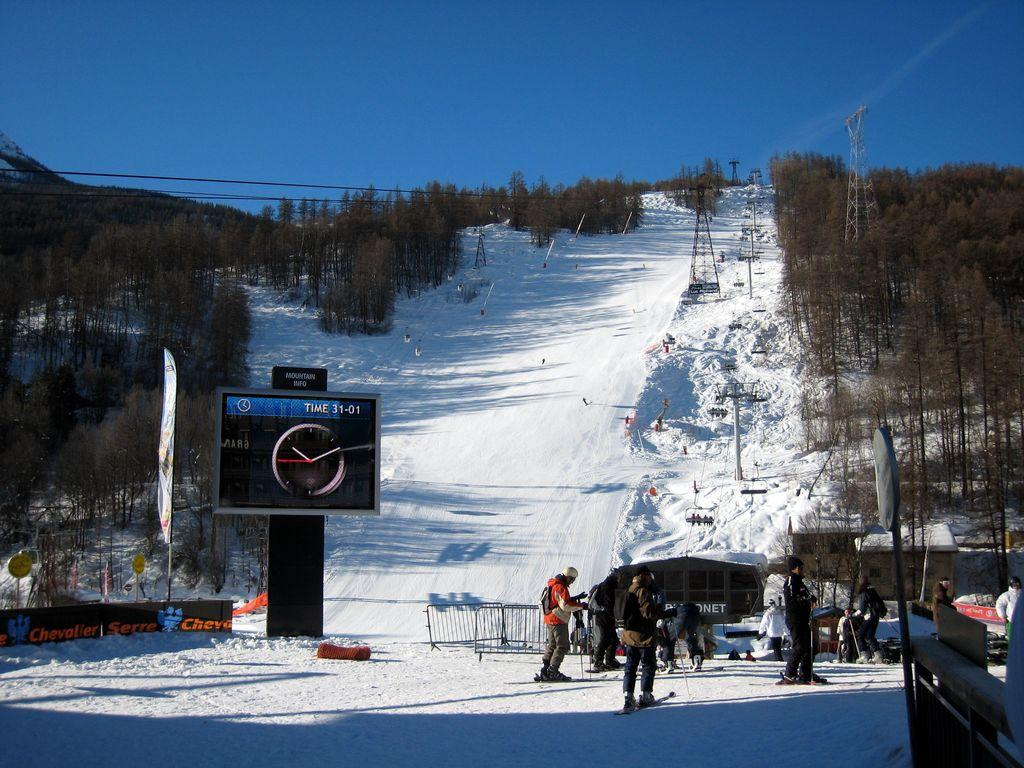What type of surface is depicted in the image? There is a piste in the image. What can be seen on the sides of the piste? The piste has trees and poles on its sides. What other objects or structures are present in the image? There are posters, boards, houses, railings, and a sign board in the image. Who or what is present on the flat ground in the image? There is a group of people on flat ground in the image. How many icicles are hanging from the trees on the piste in the image? There is no mention of icicles in the image; the trees are not described as having icicles hanging from them. What type of cannon is present on the piste in the image? There is no cannon present in the image; the piste only has trees, poles, posters, boards, houses, railings, a sign board, and a group of people on flat ground. 